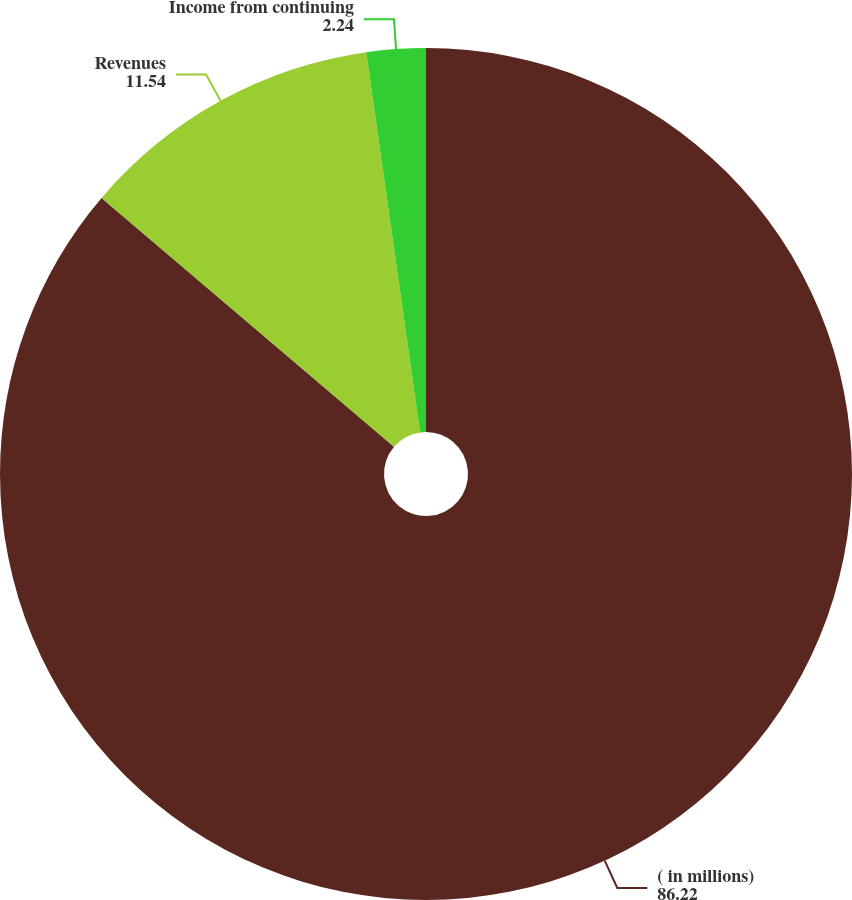Convert chart. <chart><loc_0><loc_0><loc_500><loc_500><pie_chart><fcel>( in millions)<fcel>Revenues<fcel>Income from continuing<nl><fcel>86.22%<fcel>11.54%<fcel>2.24%<nl></chart> 